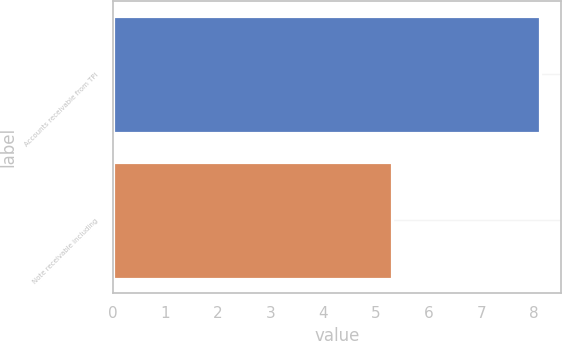<chart> <loc_0><loc_0><loc_500><loc_500><bar_chart><fcel>Accounts receivable from TPI<fcel>Note receivable including<nl><fcel>8.1<fcel>5.3<nl></chart> 